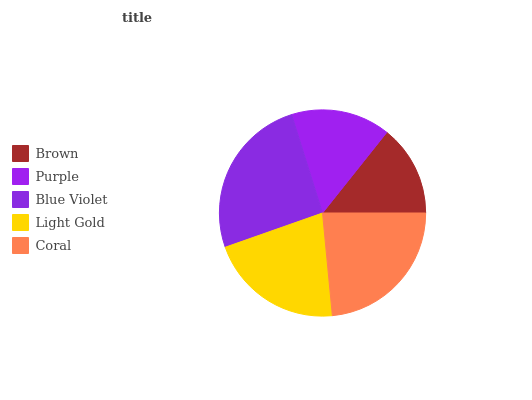Is Brown the minimum?
Answer yes or no. Yes. Is Blue Violet the maximum?
Answer yes or no. Yes. Is Purple the minimum?
Answer yes or no. No. Is Purple the maximum?
Answer yes or no. No. Is Purple greater than Brown?
Answer yes or no. Yes. Is Brown less than Purple?
Answer yes or no. Yes. Is Brown greater than Purple?
Answer yes or no. No. Is Purple less than Brown?
Answer yes or no. No. Is Light Gold the high median?
Answer yes or no. Yes. Is Light Gold the low median?
Answer yes or no. Yes. Is Purple the high median?
Answer yes or no. No. Is Brown the low median?
Answer yes or no. No. 